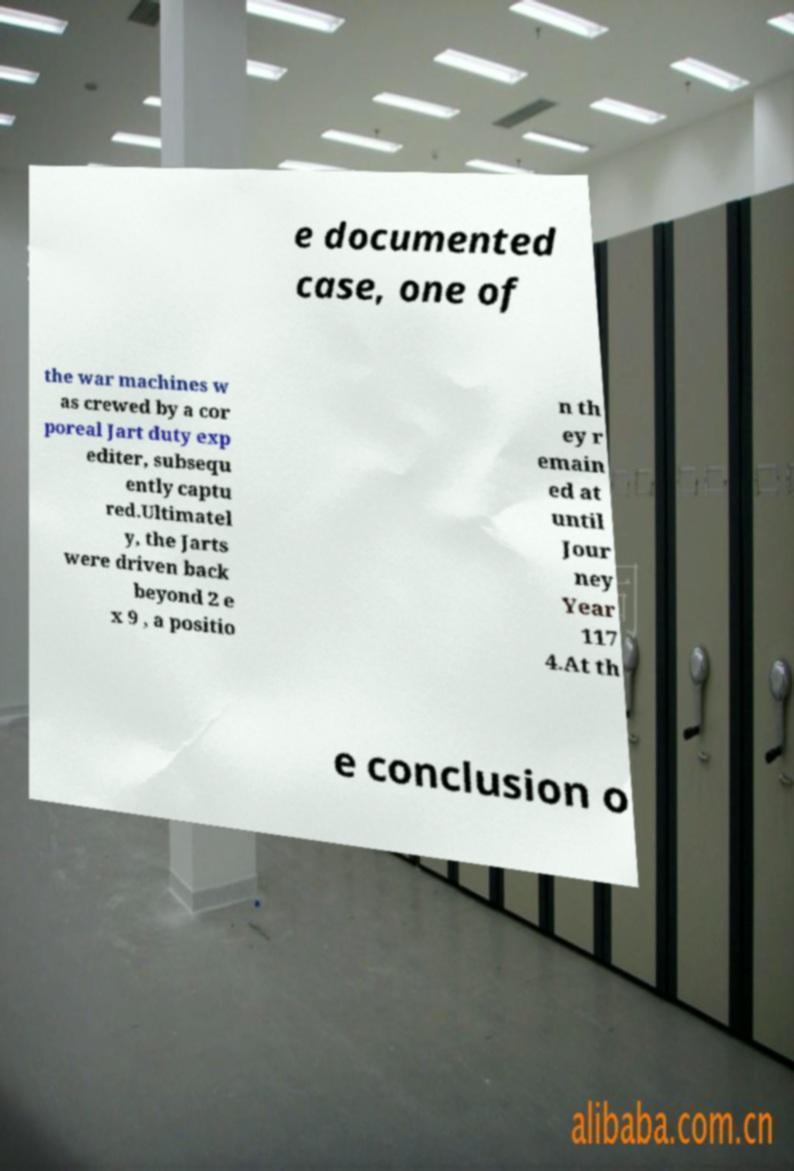There's text embedded in this image that I need extracted. Can you transcribe it verbatim? e documented case, one of the war machines w as crewed by a cor poreal Jart duty exp editer, subsequ ently captu red.Ultimatel y, the Jarts were driven back beyond 2 e x 9 , a positio n th ey r emain ed at until Jour ney Year 117 4.At th e conclusion o 